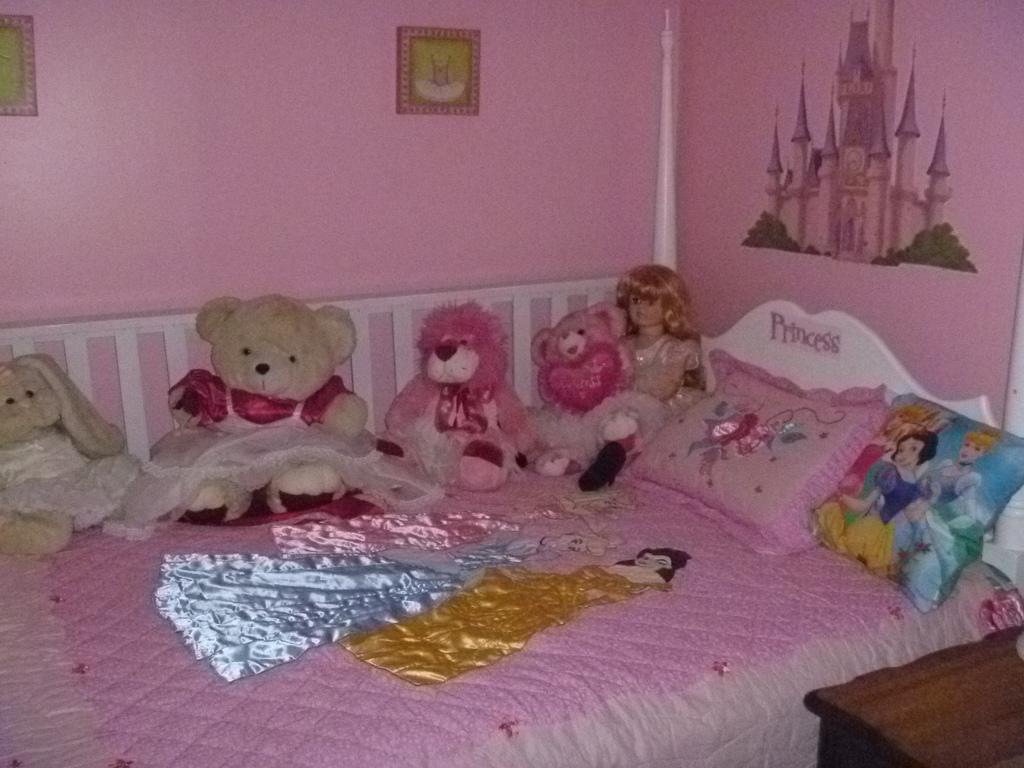How would you summarize this image in a sentence or two? This image is having a bed and different toys on it. There are two pillows and one pillow is animated images on it. One side of the wall is painted with house image, other side there is a picture frames. 